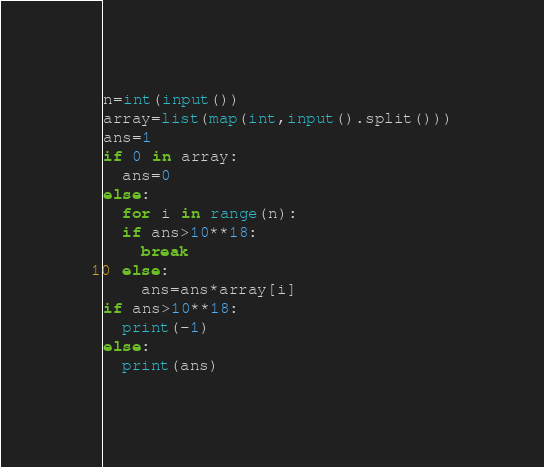<code> <loc_0><loc_0><loc_500><loc_500><_Python_>n=int(input())
array=list(map(int,input().split()))
ans=1
if 0 in array:
  ans=0
else:
  for i in range(n):
  if ans>10**18:
    break
  else:
    ans=ans*array[i]
if ans>10**18:
  print(-1)
else:
  print(ans)</code> 